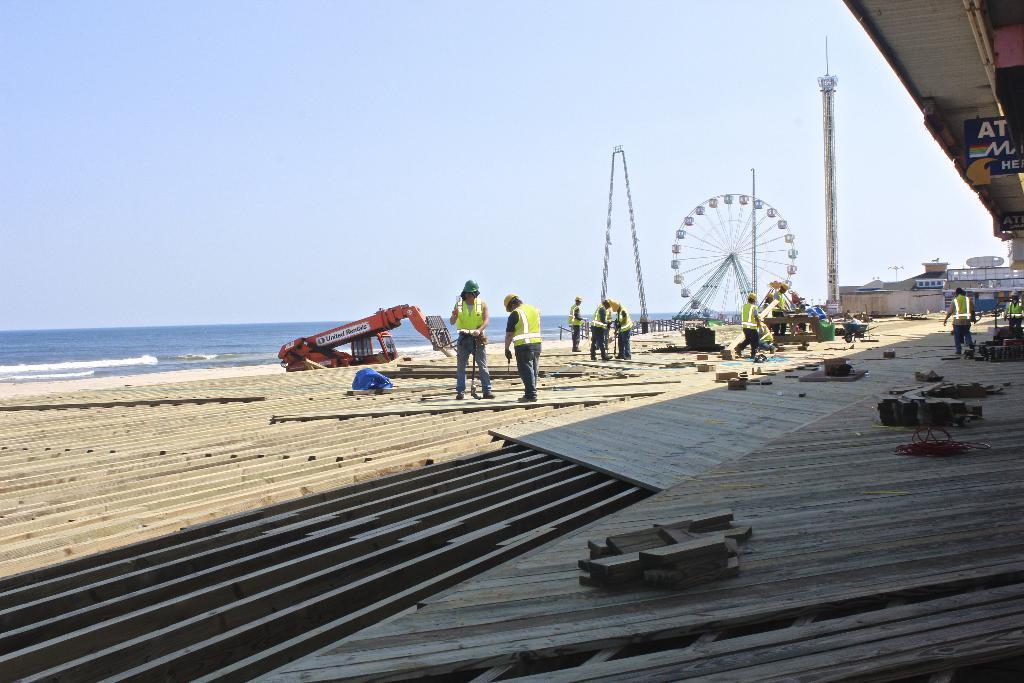How would you summarize this image in a sentence or two? In this image we can see a group of people wearing dresses and hats is standing on the floor. To the right side of the image we can see some wood pieces placed on the ground. On the left side of the image we can see a vehicle. In the background, we can see buildings, sign board with some text, a tower, Ferris wheel, poles, water and the sky. 